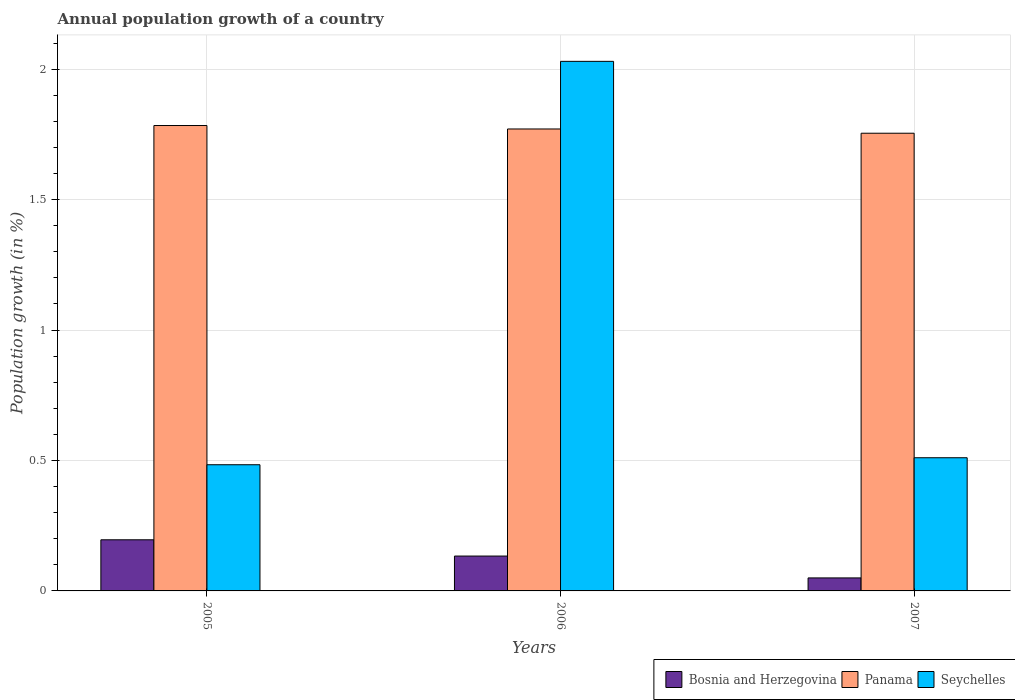How many different coloured bars are there?
Your answer should be very brief. 3. How many groups of bars are there?
Your answer should be compact. 3. Are the number of bars per tick equal to the number of legend labels?
Your answer should be compact. Yes. In how many cases, is the number of bars for a given year not equal to the number of legend labels?
Keep it short and to the point. 0. What is the annual population growth in Panama in 2005?
Your answer should be compact. 1.78. Across all years, what is the maximum annual population growth in Seychelles?
Provide a short and direct response. 2.03. Across all years, what is the minimum annual population growth in Panama?
Your answer should be very brief. 1.75. In which year was the annual population growth in Bosnia and Herzegovina maximum?
Offer a very short reply. 2005. What is the total annual population growth in Bosnia and Herzegovina in the graph?
Your response must be concise. 0.38. What is the difference between the annual population growth in Bosnia and Herzegovina in 2005 and that in 2006?
Keep it short and to the point. 0.06. What is the difference between the annual population growth in Panama in 2007 and the annual population growth in Seychelles in 2005?
Your response must be concise. 1.27. What is the average annual population growth in Seychelles per year?
Provide a succinct answer. 1.01. In the year 2007, what is the difference between the annual population growth in Bosnia and Herzegovina and annual population growth in Panama?
Ensure brevity in your answer.  -1.7. What is the ratio of the annual population growth in Seychelles in 2005 to that in 2006?
Offer a very short reply. 0.24. Is the annual population growth in Bosnia and Herzegovina in 2005 less than that in 2007?
Make the answer very short. No. What is the difference between the highest and the second highest annual population growth in Panama?
Provide a succinct answer. 0.01. What is the difference between the highest and the lowest annual population growth in Bosnia and Herzegovina?
Your answer should be very brief. 0.15. In how many years, is the annual population growth in Panama greater than the average annual population growth in Panama taken over all years?
Give a very brief answer. 2. What does the 3rd bar from the left in 2005 represents?
Make the answer very short. Seychelles. What does the 1st bar from the right in 2005 represents?
Keep it short and to the point. Seychelles. Is it the case that in every year, the sum of the annual population growth in Panama and annual population growth in Seychelles is greater than the annual population growth in Bosnia and Herzegovina?
Ensure brevity in your answer.  Yes. What is the difference between two consecutive major ticks on the Y-axis?
Make the answer very short. 0.5. Does the graph contain any zero values?
Your response must be concise. No. Does the graph contain grids?
Provide a succinct answer. Yes. How many legend labels are there?
Your answer should be very brief. 3. How are the legend labels stacked?
Ensure brevity in your answer.  Horizontal. What is the title of the graph?
Offer a terse response. Annual population growth of a country. Does "Zambia" appear as one of the legend labels in the graph?
Ensure brevity in your answer.  No. What is the label or title of the Y-axis?
Provide a short and direct response. Population growth (in %). What is the Population growth (in %) of Bosnia and Herzegovina in 2005?
Keep it short and to the point. 0.2. What is the Population growth (in %) of Panama in 2005?
Keep it short and to the point. 1.78. What is the Population growth (in %) of Seychelles in 2005?
Offer a terse response. 0.48. What is the Population growth (in %) of Bosnia and Herzegovina in 2006?
Make the answer very short. 0.13. What is the Population growth (in %) in Panama in 2006?
Offer a terse response. 1.77. What is the Population growth (in %) of Seychelles in 2006?
Offer a very short reply. 2.03. What is the Population growth (in %) in Bosnia and Herzegovina in 2007?
Provide a short and direct response. 0.05. What is the Population growth (in %) of Panama in 2007?
Give a very brief answer. 1.75. What is the Population growth (in %) in Seychelles in 2007?
Make the answer very short. 0.51. Across all years, what is the maximum Population growth (in %) in Bosnia and Herzegovina?
Make the answer very short. 0.2. Across all years, what is the maximum Population growth (in %) of Panama?
Offer a very short reply. 1.78. Across all years, what is the maximum Population growth (in %) in Seychelles?
Provide a succinct answer. 2.03. Across all years, what is the minimum Population growth (in %) of Bosnia and Herzegovina?
Provide a short and direct response. 0.05. Across all years, what is the minimum Population growth (in %) of Panama?
Offer a very short reply. 1.75. Across all years, what is the minimum Population growth (in %) in Seychelles?
Your answer should be very brief. 0.48. What is the total Population growth (in %) in Bosnia and Herzegovina in the graph?
Your answer should be very brief. 0.38. What is the total Population growth (in %) of Panama in the graph?
Give a very brief answer. 5.31. What is the total Population growth (in %) of Seychelles in the graph?
Your answer should be compact. 3.02. What is the difference between the Population growth (in %) in Bosnia and Herzegovina in 2005 and that in 2006?
Offer a terse response. 0.06. What is the difference between the Population growth (in %) of Panama in 2005 and that in 2006?
Your answer should be very brief. 0.01. What is the difference between the Population growth (in %) in Seychelles in 2005 and that in 2006?
Keep it short and to the point. -1.55. What is the difference between the Population growth (in %) of Bosnia and Herzegovina in 2005 and that in 2007?
Ensure brevity in your answer.  0.15. What is the difference between the Population growth (in %) in Panama in 2005 and that in 2007?
Keep it short and to the point. 0.03. What is the difference between the Population growth (in %) of Seychelles in 2005 and that in 2007?
Offer a terse response. -0.03. What is the difference between the Population growth (in %) in Bosnia and Herzegovina in 2006 and that in 2007?
Ensure brevity in your answer.  0.08. What is the difference between the Population growth (in %) of Panama in 2006 and that in 2007?
Your response must be concise. 0.02. What is the difference between the Population growth (in %) in Seychelles in 2006 and that in 2007?
Offer a very short reply. 1.52. What is the difference between the Population growth (in %) of Bosnia and Herzegovina in 2005 and the Population growth (in %) of Panama in 2006?
Keep it short and to the point. -1.57. What is the difference between the Population growth (in %) in Bosnia and Herzegovina in 2005 and the Population growth (in %) in Seychelles in 2006?
Provide a short and direct response. -1.83. What is the difference between the Population growth (in %) in Panama in 2005 and the Population growth (in %) in Seychelles in 2006?
Your answer should be compact. -0.25. What is the difference between the Population growth (in %) in Bosnia and Herzegovina in 2005 and the Population growth (in %) in Panama in 2007?
Provide a succinct answer. -1.56. What is the difference between the Population growth (in %) of Bosnia and Herzegovina in 2005 and the Population growth (in %) of Seychelles in 2007?
Give a very brief answer. -0.31. What is the difference between the Population growth (in %) of Panama in 2005 and the Population growth (in %) of Seychelles in 2007?
Offer a terse response. 1.27. What is the difference between the Population growth (in %) of Bosnia and Herzegovina in 2006 and the Population growth (in %) of Panama in 2007?
Keep it short and to the point. -1.62. What is the difference between the Population growth (in %) of Bosnia and Herzegovina in 2006 and the Population growth (in %) of Seychelles in 2007?
Provide a short and direct response. -0.38. What is the difference between the Population growth (in %) of Panama in 2006 and the Population growth (in %) of Seychelles in 2007?
Keep it short and to the point. 1.26. What is the average Population growth (in %) of Bosnia and Herzegovina per year?
Your answer should be very brief. 0.13. What is the average Population growth (in %) of Panama per year?
Offer a very short reply. 1.77. What is the average Population growth (in %) of Seychelles per year?
Your response must be concise. 1.01. In the year 2005, what is the difference between the Population growth (in %) of Bosnia and Herzegovina and Population growth (in %) of Panama?
Make the answer very short. -1.59. In the year 2005, what is the difference between the Population growth (in %) of Bosnia and Herzegovina and Population growth (in %) of Seychelles?
Give a very brief answer. -0.29. In the year 2005, what is the difference between the Population growth (in %) of Panama and Population growth (in %) of Seychelles?
Your response must be concise. 1.3. In the year 2006, what is the difference between the Population growth (in %) of Bosnia and Herzegovina and Population growth (in %) of Panama?
Provide a short and direct response. -1.64. In the year 2006, what is the difference between the Population growth (in %) of Bosnia and Herzegovina and Population growth (in %) of Seychelles?
Your response must be concise. -1.9. In the year 2006, what is the difference between the Population growth (in %) of Panama and Population growth (in %) of Seychelles?
Make the answer very short. -0.26. In the year 2007, what is the difference between the Population growth (in %) in Bosnia and Herzegovina and Population growth (in %) in Panama?
Provide a short and direct response. -1.7. In the year 2007, what is the difference between the Population growth (in %) in Bosnia and Herzegovina and Population growth (in %) in Seychelles?
Your response must be concise. -0.46. In the year 2007, what is the difference between the Population growth (in %) of Panama and Population growth (in %) of Seychelles?
Your answer should be very brief. 1.24. What is the ratio of the Population growth (in %) of Bosnia and Herzegovina in 2005 to that in 2006?
Your response must be concise. 1.47. What is the ratio of the Population growth (in %) in Panama in 2005 to that in 2006?
Your answer should be compact. 1.01. What is the ratio of the Population growth (in %) of Seychelles in 2005 to that in 2006?
Your response must be concise. 0.24. What is the ratio of the Population growth (in %) in Bosnia and Herzegovina in 2005 to that in 2007?
Offer a terse response. 3.93. What is the ratio of the Population growth (in %) of Panama in 2005 to that in 2007?
Make the answer very short. 1.02. What is the ratio of the Population growth (in %) in Seychelles in 2005 to that in 2007?
Your response must be concise. 0.95. What is the ratio of the Population growth (in %) of Bosnia and Herzegovina in 2006 to that in 2007?
Provide a short and direct response. 2.68. What is the ratio of the Population growth (in %) in Panama in 2006 to that in 2007?
Keep it short and to the point. 1.01. What is the ratio of the Population growth (in %) in Seychelles in 2006 to that in 2007?
Offer a terse response. 3.98. What is the difference between the highest and the second highest Population growth (in %) of Bosnia and Herzegovina?
Make the answer very short. 0.06. What is the difference between the highest and the second highest Population growth (in %) in Panama?
Offer a very short reply. 0.01. What is the difference between the highest and the second highest Population growth (in %) in Seychelles?
Your answer should be compact. 1.52. What is the difference between the highest and the lowest Population growth (in %) in Bosnia and Herzegovina?
Your answer should be compact. 0.15. What is the difference between the highest and the lowest Population growth (in %) of Panama?
Ensure brevity in your answer.  0.03. What is the difference between the highest and the lowest Population growth (in %) of Seychelles?
Your answer should be compact. 1.55. 